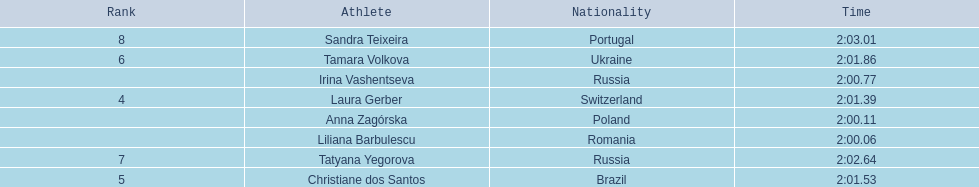What are the names of the competitors? Liliana Barbulescu, Anna Zagórska, Irina Vashentseva, Laura Gerber, Christiane dos Santos, Tamara Volkova, Tatyana Yegorova, Sandra Teixeira. Which finalist finished the fastest? Liliana Barbulescu. 